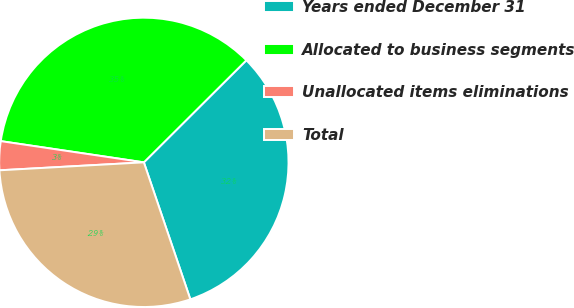Convert chart to OTSL. <chart><loc_0><loc_0><loc_500><loc_500><pie_chart><fcel>Years ended December 31<fcel>Allocated to business segments<fcel>Unallocated items eliminations<fcel>Total<nl><fcel>32.26%<fcel>35.19%<fcel>3.22%<fcel>29.33%<nl></chart> 